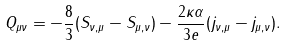<formula> <loc_0><loc_0><loc_500><loc_500>Q _ { \mu \nu } = - \frac { 8 } { 3 } ( S _ { \nu , \mu } - S _ { \mu , \nu } ) - \frac { 2 \kappa \alpha } { 3 e } ( j _ { \nu , \mu } - j _ { \mu , \nu } ) .</formula> 